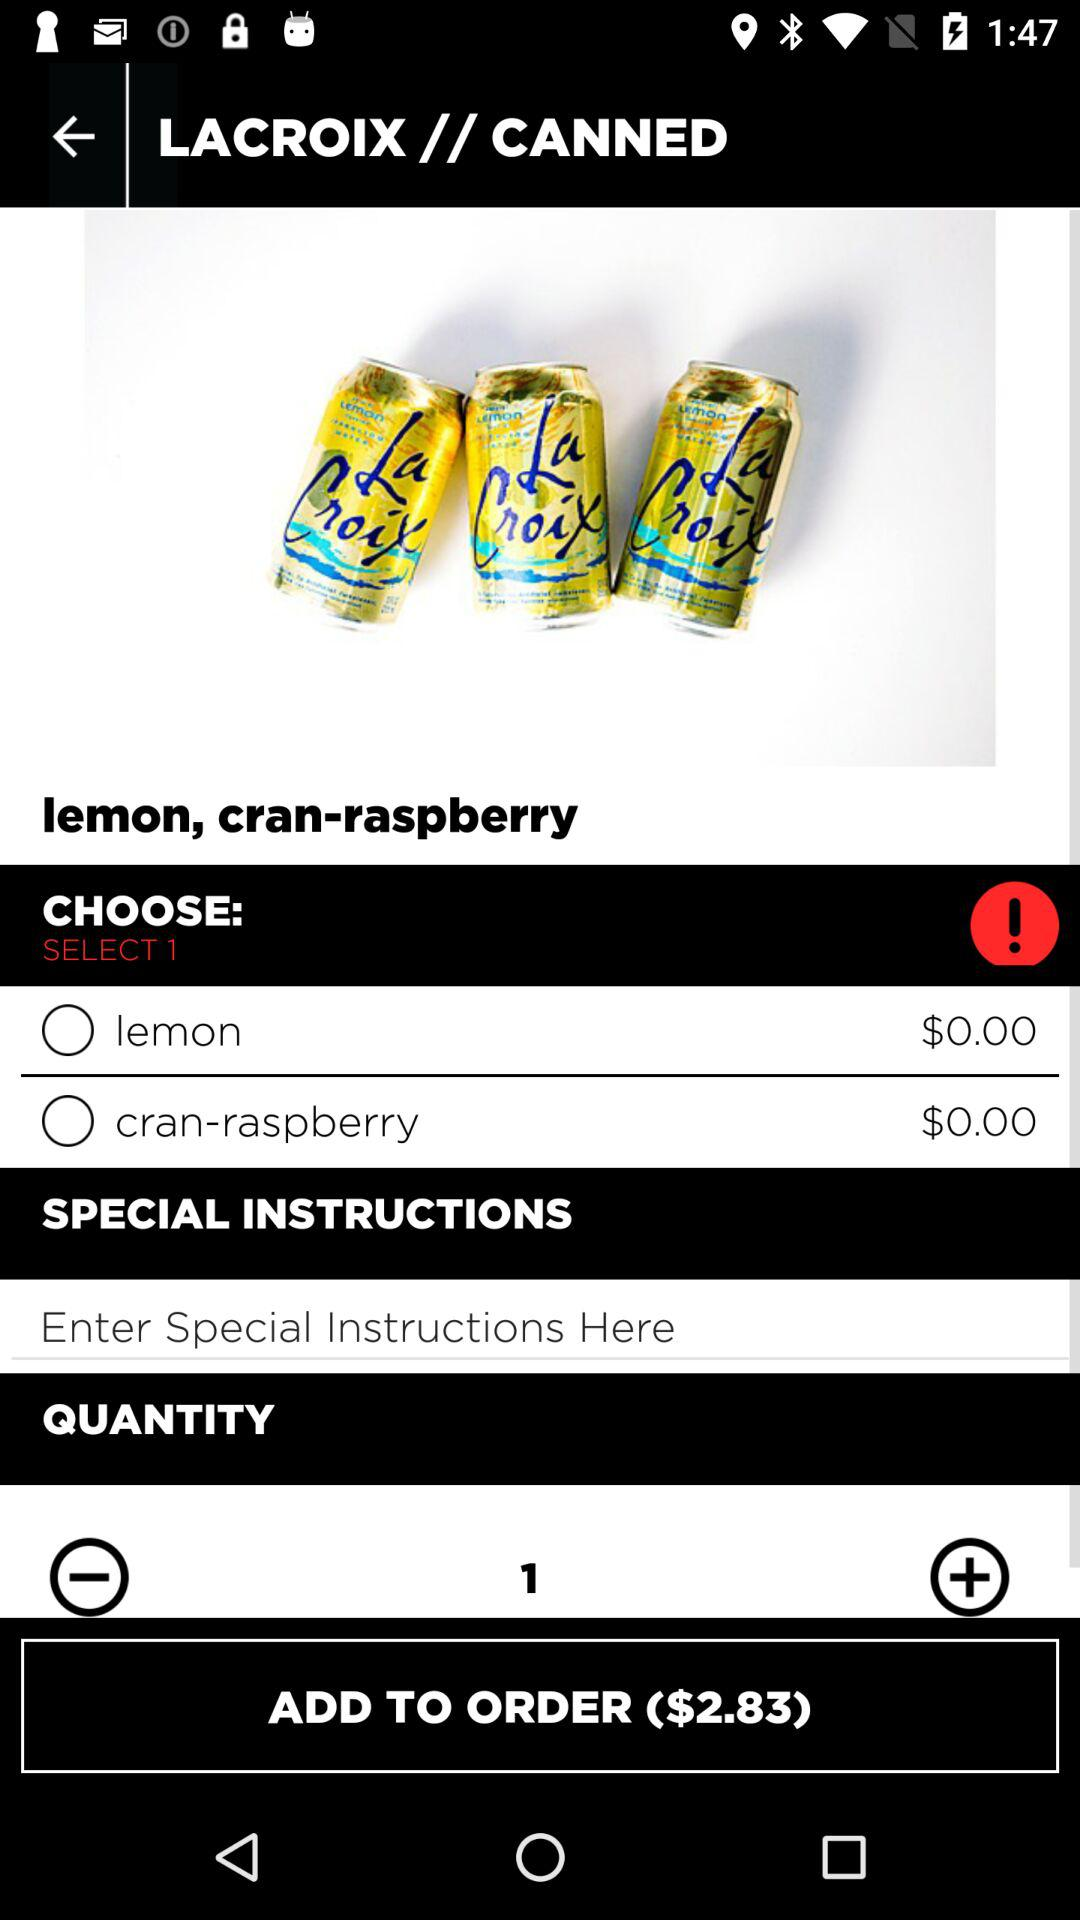What is the total quantity? The total quantity is 1. 